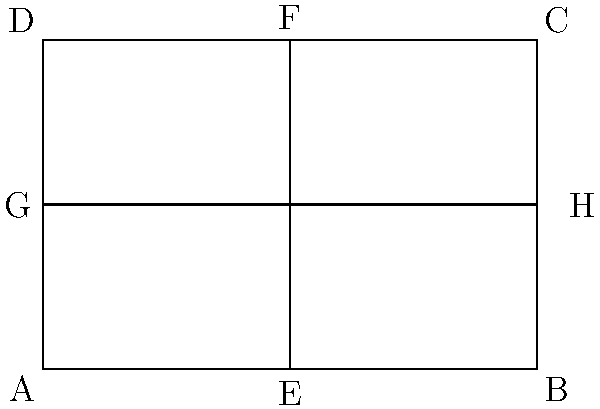Remember when we used to fold paper in art class? Let's revisit that! A rectangular piece of paper ABCD is folded along its vertical line of symmetry EF and horizontal line of symmetry GH, creating four congruent quadrilaterals. If the area of the entire rectangle is 24 square units, what is the area of quadrilateral AEHG? Let's approach this step-by-step:

1) First, we need to recognize that the rectangle is divided into four congruent quadrilaterals by its lines of symmetry.

2) Since these quadrilaterals are congruent, they must have equal areas.

3) The total area of the rectangle is given as 24 square units.

4) To find the area of one quadrilateral, we need to divide the total area by 4:

   $$\text{Area of one quadrilateral} = \frac{\text{Total area}}{4} = \frac{24}{4} = 6\text{ square units}$$

5) Quadrilateral AEHG is one of these four congruent quadrilaterals.

Therefore, the area of quadrilateral AEHG is 6 square units.
Answer: 6 square units 